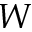Convert formula to latex. <formula><loc_0><loc_0><loc_500><loc_500>W</formula> 